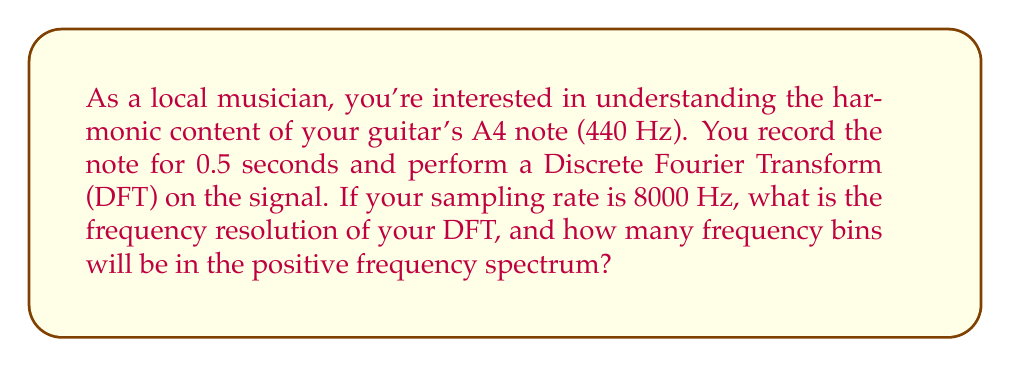Solve this math problem. Let's approach this step-by-step:

1) First, we need to calculate the total number of samples in the signal:
   
   Sample duration = 0.5 seconds
   Sampling rate = 8000 Hz
   
   Total samples = $0.5 \times 8000 = 4000$ samples

2) The frequency resolution of a DFT is given by:

   $$\Delta f = \frac{f_s}{N}$$

   Where $f_s$ is the sampling rate and $N$ is the number of samples.

3) Plugging in our values:

   $$\Delta f = \frac{8000}{4000} = 2 \text{ Hz}$$

4) To find the number of frequency bins in the positive spectrum, we need to consider that the DFT produces $N$ total bins, but only half of these represent positive frequencies (the other half are negative frequencies or complex conjugates).

5) The number of positive frequency bins is:

   $$\frac{N}{2} = \frac{4000}{2} = 2000 \text{ bins}$$

6) However, this includes the DC component (0 Hz). If we're only interested in non-zero frequencies, we subtract 1:

   $2000 - 1 = 1999$ bins for positive, non-zero frequencies.
Answer: Frequency resolution: 2 Hz, Number of positive frequency bins: 1999 